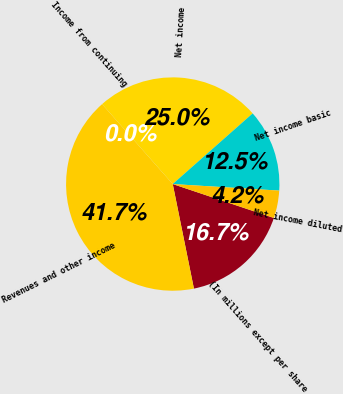Convert chart. <chart><loc_0><loc_0><loc_500><loc_500><pie_chart><fcel>(In millions except per share<fcel>Revenues and other income<fcel>Income from continuing<fcel>Net income<fcel>Net income basic<fcel>Net income diluted<nl><fcel>16.67%<fcel>41.66%<fcel>0.0%<fcel>25.0%<fcel>12.5%<fcel>4.17%<nl></chart> 